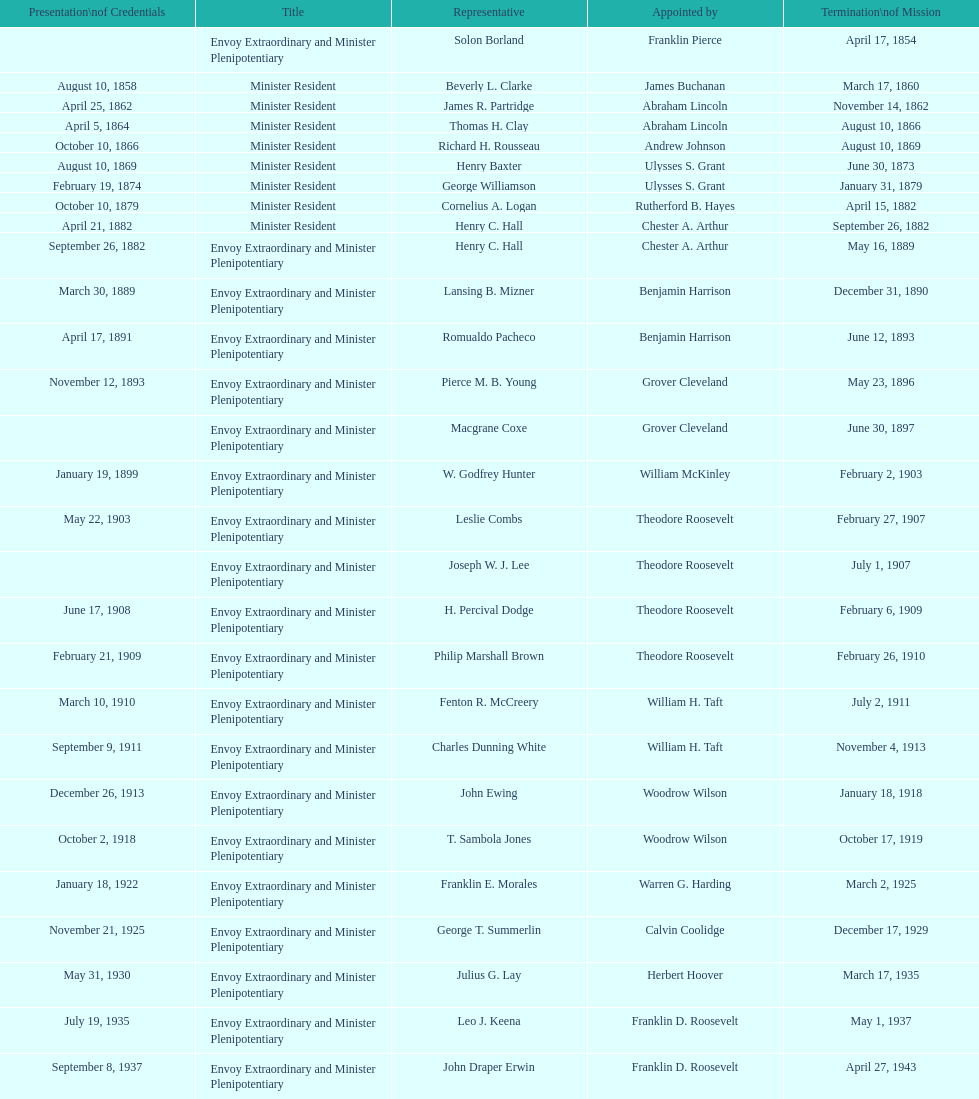Could you parse the entire table as a dict? {'header': ['Presentation\\nof Credentials', 'Title', 'Representative', 'Appointed by', 'Termination\\nof Mission'], 'rows': [['', 'Envoy Extraordinary and Minister Plenipotentiary', 'Solon Borland', 'Franklin Pierce', 'April 17, 1854'], ['August 10, 1858', 'Minister Resident', 'Beverly L. Clarke', 'James Buchanan', 'March 17, 1860'], ['April 25, 1862', 'Minister Resident', 'James R. Partridge', 'Abraham Lincoln', 'November 14, 1862'], ['April 5, 1864', 'Minister Resident', 'Thomas H. Clay', 'Abraham Lincoln', 'August 10, 1866'], ['October 10, 1866', 'Minister Resident', 'Richard H. Rousseau', 'Andrew Johnson', 'August 10, 1869'], ['August 10, 1869', 'Minister Resident', 'Henry Baxter', 'Ulysses S. Grant', 'June 30, 1873'], ['February 19, 1874', 'Minister Resident', 'George Williamson', 'Ulysses S. Grant', 'January 31, 1879'], ['October 10, 1879', 'Minister Resident', 'Cornelius A. Logan', 'Rutherford B. Hayes', 'April 15, 1882'], ['April 21, 1882', 'Minister Resident', 'Henry C. Hall', 'Chester A. Arthur', 'September 26, 1882'], ['September 26, 1882', 'Envoy Extraordinary and Minister Plenipotentiary', 'Henry C. Hall', 'Chester A. Arthur', 'May 16, 1889'], ['March 30, 1889', 'Envoy Extraordinary and Minister Plenipotentiary', 'Lansing B. Mizner', 'Benjamin Harrison', 'December 31, 1890'], ['April 17, 1891', 'Envoy Extraordinary and Minister Plenipotentiary', 'Romualdo Pacheco', 'Benjamin Harrison', 'June 12, 1893'], ['November 12, 1893', 'Envoy Extraordinary and Minister Plenipotentiary', 'Pierce M. B. Young', 'Grover Cleveland', 'May 23, 1896'], ['', 'Envoy Extraordinary and Minister Plenipotentiary', 'Macgrane Coxe', 'Grover Cleveland', 'June 30, 1897'], ['January 19, 1899', 'Envoy Extraordinary and Minister Plenipotentiary', 'W. Godfrey Hunter', 'William McKinley', 'February 2, 1903'], ['May 22, 1903', 'Envoy Extraordinary and Minister Plenipotentiary', 'Leslie Combs', 'Theodore Roosevelt', 'February 27, 1907'], ['', 'Envoy Extraordinary and Minister Plenipotentiary', 'Joseph W. J. Lee', 'Theodore Roosevelt', 'July 1, 1907'], ['June 17, 1908', 'Envoy Extraordinary and Minister Plenipotentiary', 'H. Percival Dodge', 'Theodore Roosevelt', 'February 6, 1909'], ['February 21, 1909', 'Envoy Extraordinary and Minister Plenipotentiary', 'Philip Marshall Brown', 'Theodore Roosevelt', 'February 26, 1910'], ['March 10, 1910', 'Envoy Extraordinary and Minister Plenipotentiary', 'Fenton R. McCreery', 'William H. Taft', 'July 2, 1911'], ['September 9, 1911', 'Envoy Extraordinary and Minister Plenipotentiary', 'Charles Dunning White', 'William H. Taft', 'November 4, 1913'], ['December 26, 1913', 'Envoy Extraordinary and Minister Plenipotentiary', 'John Ewing', 'Woodrow Wilson', 'January 18, 1918'], ['October 2, 1918', 'Envoy Extraordinary and Minister Plenipotentiary', 'T. Sambola Jones', 'Woodrow Wilson', 'October 17, 1919'], ['January 18, 1922', 'Envoy Extraordinary and Minister Plenipotentiary', 'Franklin E. Morales', 'Warren G. Harding', 'March 2, 1925'], ['November 21, 1925', 'Envoy Extraordinary and Minister Plenipotentiary', 'George T. Summerlin', 'Calvin Coolidge', 'December 17, 1929'], ['May 31, 1930', 'Envoy Extraordinary and Minister Plenipotentiary', 'Julius G. Lay', 'Herbert Hoover', 'March 17, 1935'], ['July 19, 1935', 'Envoy Extraordinary and Minister Plenipotentiary', 'Leo J. Keena', 'Franklin D. Roosevelt', 'May 1, 1937'], ['September 8, 1937', 'Envoy Extraordinary and Minister Plenipotentiary', 'John Draper Erwin', 'Franklin D. Roosevelt', 'April 27, 1943'], ['April 27, 1943', 'Ambassador Extraordinary and Plenipotentiary', 'John Draper Erwin', 'Franklin D. Roosevelt', 'April 16, 1947'], ['June 23, 1947', 'Ambassador Extraordinary and Plenipotentiary', 'Paul C. Daniels', 'Harry S. Truman', 'October 30, 1947'], ['May 15, 1948', 'Ambassador Extraordinary and Plenipotentiary', 'Herbert S. Bursley', 'Harry S. Truman', 'December 12, 1950'], ['March 14, 1951', 'Ambassador Extraordinary and Plenipotentiary', 'John Draper Erwin', 'Harry S. Truman', 'February 28, 1954'], ['March 5, 1954', 'Ambassador Extraordinary and Plenipotentiary', 'Whiting Willauer', 'Dwight D. Eisenhower', 'March 24, 1958'], ['April 30, 1958', 'Ambassador Extraordinary and Plenipotentiary', 'Robert Newbegin', 'Dwight D. Eisenhower', 'August 3, 1960'], ['November 3, 1960', 'Ambassador Extraordinary and Plenipotentiary', 'Charles R. Burrows', 'Dwight D. Eisenhower', 'June 28, 1965'], ['July 12, 1965', 'Ambassador Extraordinary and Plenipotentiary', 'Joseph J. Jova', 'Lyndon B. Johnson', 'June 21, 1969'], ['November 5, 1969', 'Ambassador Extraordinary and Plenipotentiary', 'Hewson A. Ryan', 'Richard Nixon', 'May 30, 1973'], ['June 15, 1973', 'Ambassador Extraordinary and Plenipotentiary', 'Phillip V. Sanchez', 'Richard Nixon', 'July 17, 1976'], ['October 27, 1976', 'Ambassador Extraordinary and Plenipotentiary', 'Ralph E. Becker', 'Gerald Ford', 'August 1, 1977'], ['October 27, 1977', 'Ambassador Extraordinary and Plenipotentiary', 'Mari-Luci Jaramillo', 'Jimmy Carter', 'September 19, 1980'], ['October 10, 1980', 'Ambassador Extraordinary and Plenipotentiary', 'Jack R. Binns', 'Jimmy Carter', 'October 31, 1981'], ['November 11, 1981', 'Ambassador Extraordinary and Plenipotentiary', 'John D. Negroponte', 'Ronald Reagan', 'May 30, 1985'], ['August 22, 1985', 'Ambassador Extraordinary and Plenipotentiary', 'John Arthur Ferch', 'Ronald Reagan', 'July 9, 1986'], ['November 4, 1986', 'Ambassador Extraordinary and Plenipotentiary', 'Everett Ellis Briggs', 'Ronald Reagan', 'June 15, 1989'], ['January 29, 1990', 'Ambassador Extraordinary and Plenipotentiary', 'Cresencio S. Arcos, Jr.', 'George H. W. Bush', 'July 1, 1993'], ['July 21, 1993', 'Ambassador Extraordinary and Plenipotentiary', 'William Thornton Pryce', 'Bill Clinton', 'August 15, 1996'], ['August 29, 1996', 'Ambassador Extraordinary and Plenipotentiary', 'James F. Creagan', 'Bill Clinton', 'July 20, 1999'], ['August 25, 1999', 'Ambassador Extraordinary and Plenipotentiary', 'Frank Almaguer', 'Bill Clinton', 'September 5, 2002'], ['October 8, 2002', 'Ambassador Extraordinary and Plenipotentiary', 'Larry Leon Palmer', 'George W. Bush', 'May 7, 2005'], ['November 8, 2005', 'Ambassador Extraordinary and Plenipotentiary', 'Charles A. Ford', 'George W. Bush', 'ca. April 2008'], ['September 19, 2008', 'Ambassador Extraordinary and Plenipotentiary', 'Hugo Llorens', 'George W. Bush', 'ca. July 2011'], ['July 26, 2011', 'Ambassador Extraordinary and Plenipotentiary', 'Lisa Kubiske', 'Barack Obama', 'Incumbent']]} What was the length, in years, of leslie combs' term? 4 years. 